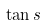<formula> <loc_0><loc_0><loc_500><loc_500>\tan s</formula> 